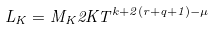Convert formula to latex. <formula><loc_0><loc_0><loc_500><loc_500>L _ { K } = M _ { K } 2 K T ^ { k + 2 ( r + q + 1 ) - \mu }</formula> 